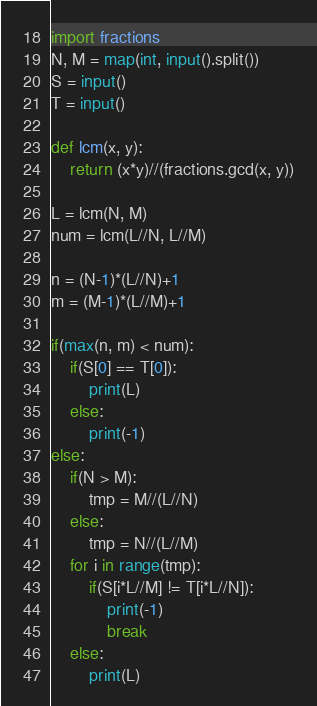Convert code to text. <code><loc_0><loc_0><loc_500><loc_500><_Python_>import fractions
N, M = map(int, input().split())
S = input()
T = input()

def lcm(x, y):
    return (x*y)//(fractions.gcd(x, y))

L = lcm(N, M)
num = lcm(L//N, L//M)

n = (N-1)*(L//N)+1
m = (M-1)*(L//M)+1

if(max(n, m) < num):
    if(S[0] == T[0]):
        print(L)
    else:
        print(-1)
else:
    if(N > M):
        tmp = M//(L//N)
    else:
        tmp = N//(L//M)
    for i in range(tmp):
        if(S[i*L//M] != T[i*L//N]):
            print(-1)
            break
    else:
        print(L)</code> 